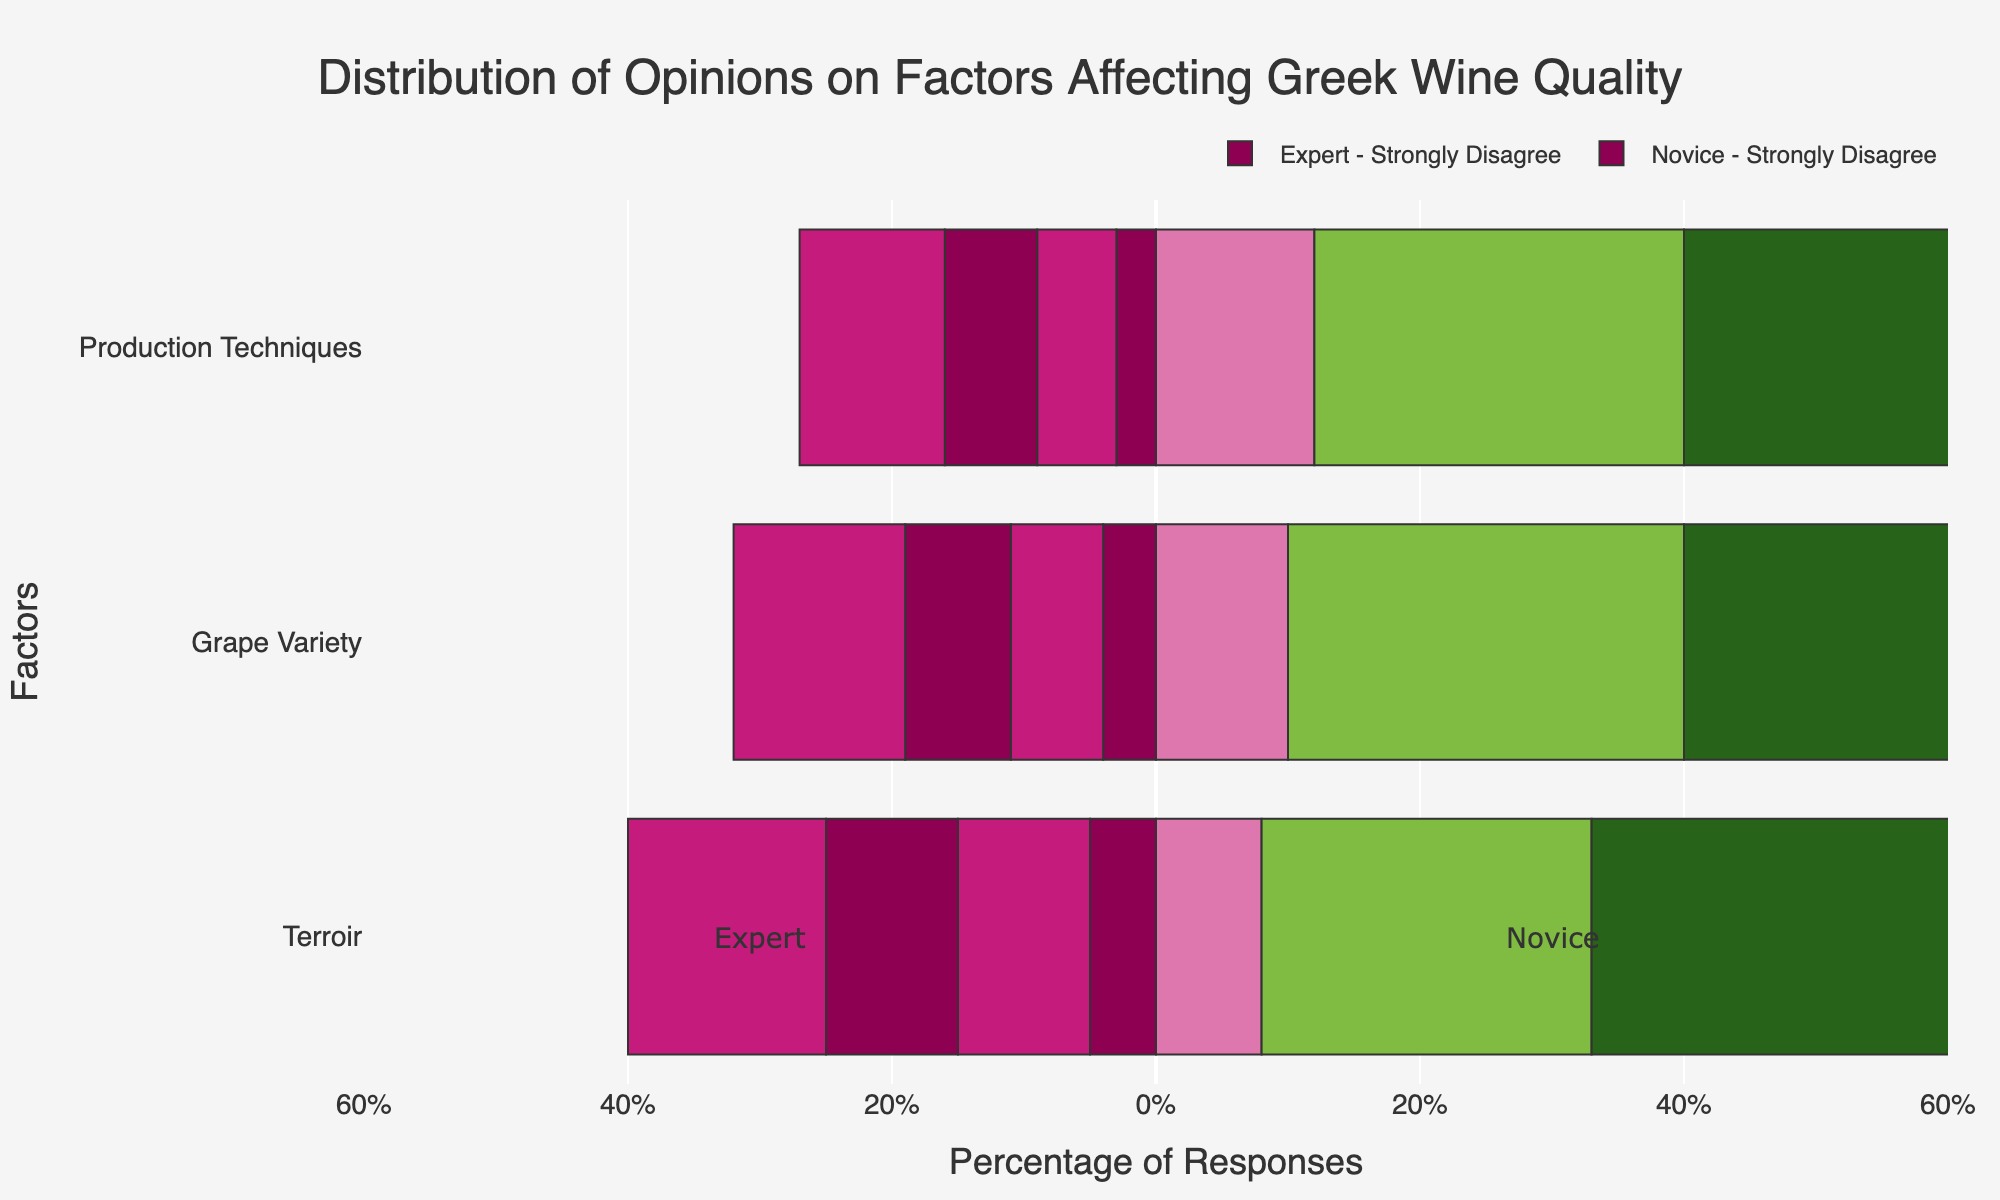Which factor do experts most strongly agree affects Greek wine quality? By examining the length of the bars for experts under each category, the "Strongly Agree" section is highest for "Terroir" at 52.
Answer: Terroir How do novices' opinions on grape variety compare to experts' when strongly agreeing? Compare the length of the "Strongly Agree" bars for novices and experts on grape variety: novices have 29 and experts have 49.
Answer: Experts agree more What is the combined percentage of experts who agree or strongly agree that production techniques affect wine quality? Add the "Agree" and "Strongly Agree" values for experts on production techniques: 28 + 51 = 79.
Answer: 79% What is the difference between the number of novices who are neutral about terroir and those who disagree? Subtract the "Disagree" value from the "Neutral" value for novices on terroir: 20 - 15 = 5.
Answer: 5 Do experts or novices have more people who disagree that grape variety affects wine quality? Compare the "Disagree" bars for experts and novices on grape variety: experts have 7, novices have 13.
Answer: Novices Which factor has the highest neutral opinion among novices? Look at the "Neutral" bars for novices by factor: production techniques (22), grape variety (18), terroir (20). Production techniques are the highest.
Answer: Production Techniques What percentage of experts strongly disagree that grape variety affects Greek wine quality? Experts' "Strongly Disagree" bar for grape variety is 4. The total is 100, so (4/100)*100 = 4.
Answer: 4% Which expertise level has a stronger consensus on the importance of terroir? Experts show higher "Agree" and "Strongly Agree" combined (25+52) compared to novices (30+25). Experts show stronger consensus.
Answer: Experts 